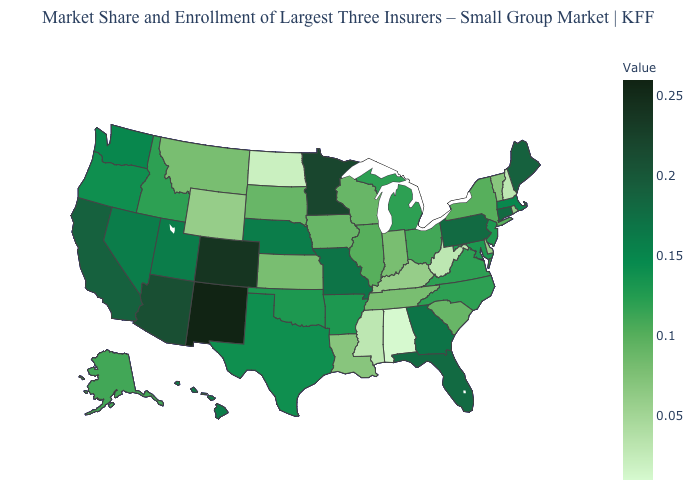Does Nebraska have a lower value than Iowa?
Answer briefly. No. Does the map have missing data?
Keep it brief. No. Which states have the highest value in the USA?
Quick response, please. New Mexico. Which states have the lowest value in the USA?
Write a very short answer. Alabama. Among the states that border Illinois , does Missouri have the highest value?
Write a very short answer. Yes. 